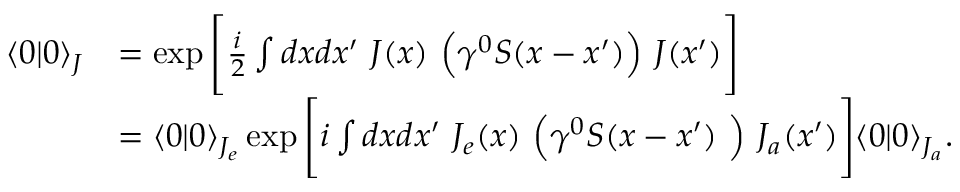Convert formula to latex. <formula><loc_0><loc_0><loc_500><loc_500>{ \begin{array} { r l } { \langle 0 | 0 \rangle _ { J } } & { = \exp { { \left [ } { \frac { i } { 2 } } \int d x d x ^ { \prime } J ( x ) { \left ( } \gamma ^ { 0 } S ( x - x ^ { \prime } ) { \right ) } J ( x ^ { \prime } ) { \right ] } } } \\ & { = \langle 0 | 0 \rangle _ { J _ { e } } \exp { { \left [ } i \int d x d x ^ { \prime } J _ { e } ( x ) { \left ( } \gamma ^ { 0 } S ( x - x ^ { \prime } ) { \right ) } J _ { a } ( x ^ { \prime } ) { \right ] } } \langle 0 | 0 \rangle _ { J _ { a } } . } \end{array} }</formula> 